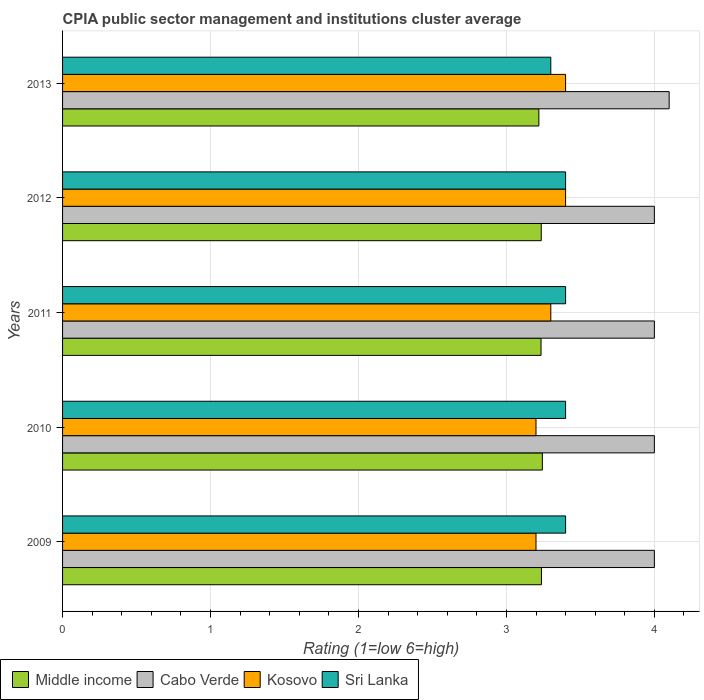How many different coloured bars are there?
Give a very brief answer. 4. Are the number of bars per tick equal to the number of legend labels?
Offer a terse response. Yes. Are the number of bars on each tick of the Y-axis equal?
Provide a short and direct response. Yes. How many bars are there on the 4th tick from the top?
Your answer should be very brief. 4. How many bars are there on the 4th tick from the bottom?
Your response must be concise. 4. What is the label of the 3rd group of bars from the top?
Provide a short and direct response. 2011. In how many cases, is the number of bars for a given year not equal to the number of legend labels?
Ensure brevity in your answer.  0. What is the CPIA rating in Cabo Verde in 2013?
Your response must be concise. 4.1. Across all years, what is the minimum CPIA rating in Sri Lanka?
Your answer should be very brief. 3.3. In which year was the CPIA rating in Cabo Verde minimum?
Give a very brief answer. 2009. What is the total CPIA rating in Cabo Verde in the graph?
Give a very brief answer. 20.1. What is the difference between the CPIA rating in Kosovo in 2011 and that in 2012?
Offer a terse response. -0.1. What is the difference between the CPIA rating in Middle income in 2011 and the CPIA rating in Sri Lanka in 2013?
Your answer should be very brief. -0.07. What is the average CPIA rating in Cabo Verde per year?
Ensure brevity in your answer.  4.02. In the year 2013, what is the difference between the CPIA rating in Kosovo and CPIA rating in Cabo Verde?
Keep it short and to the point. -0.7. In how many years, is the CPIA rating in Sri Lanka greater than 1 ?
Offer a very short reply. 5. What is the ratio of the CPIA rating in Cabo Verde in 2011 to that in 2013?
Offer a very short reply. 0.98. What is the difference between the highest and the second highest CPIA rating in Sri Lanka?
Provide a succinct answer. 0. What is the difference between the highest and the lowest CPIA rating in Kosovo?
Your response must be concise. 0.2. In how many years, is the CPIA rating in Kosovo greater than the average CPIA rating in Kosovo taken over all years?
Give a very brief answer. 2. Is it the case that in every year, the sum of the CPIA rating in Sri Lanka and CPIA rating in Kosovo is greater than the sum of CPIA rating in Cabo Verde and CPIA rating in Middle income?
Provide a short and direct response. No. What does the 1st bar from the bottom in 2009 represents?
Make the answer very short. Middle income. Is it the case that in every year, the sum of the CPIA rating in Middle income and CPIA rating in Cabo Verde is greater than the CPIA rating in Sri Lanka?
Give a very brief answer. Yes. Are all the bars in the graph horizontal?
Offer a very short reply. Yes. How many years are there in the graph?
Your answer should be very brief. 5. Does the graph contain any zero values?
Give a very brief answer. No. How many legend labels are there?
Offer a terse response. 4. How are the legend labels stacked?
Provide a succinct answer. Horizontal. What is the title of the graph?
Offer a very short reply. CPIA public sector management and institutions cluster average. What is the Rating (1=low 6=high) of Middle income in 2009?
Provide a succinct answer. 3.24. What is the Rating (1=low 6=high) of Cabo Verde in 2009?
Offer a very short reply. 4. What is the Rating (1=low 6=high) in Sri Lanka in 2009?
Offer a terse response. 3.4. What is the Rating (1=low 6=high) in Middle income in 2010?
Your answer should be very brief. 3.24. What is the Rating (1=low 6=high) in Cabo Verde in 2010?
Offer a very short reply. 4. What is the Rating (1=low 6=high) in Kosovo in 2010?
Offer a terse response. 3.2. What is the Rating (1=low 6=high) in Middle income in 2011?
Provide a succinct answer. 3.23. What is the Rating (1=low 6=high) of Cabo Verde in 2011?
Ensure brevity in your answer.  4. What is the Rating (1=low 6=high) of Sri Lanka in 2011?
Your answer should be very brief. 3.4. What is the Rating (1=low 6=high) of Middle income in 2012?
Offer a terse response. 3.24. What is the Rating (1=low 6=high) of Cabo Verde in 2012?
Your answer should be very brief. 4. What is the Rating (1=low 6=high) in Kosovo in 2012?
Provide a succinct answer. 3.4. What is the Rating (1=low 6=high) of Middle income in 2013?
Keep it short and to the point. 3.22. Across all years, what is the maximum Rating (1=low 6=high) in Middle income?
Provide a short and direct response. 3.24. Across all years, what is the maximum Rating (1=low 6=high) of Kosovo?
Offer a terse response. 3.4. Across all years, what is the minimum Rating (1=low 6=high) of Middle income?
Your answer should be very brief. 3.22. Across all years, what is the minimum Rating (1=low 6=high) of Cabo Verde?
Your response must be concise. 4. Across all years, what is the minimum Rating (1=low 6=high) of Kosovo?
Your answer should be compact. 3.2. Across all years, what is the minimum Rating (1=low 6=high) of Sri Lanka?
Your answer should be compact. 3.3. What is the total Rating (1=low 6=high) in Middle income in the graph?
Make the answer very short. 16.17. What is the total Rating (1=low 6=high) of Cabo Verde in the graph?
Your answer should be compact. 20.1. What is the total Rating (1=low 6=high) in Kosovo in the graph?
Provide a succinct answer. 16.5. What is the total Rating (1=low 6=high) of Sri Lanka in the graph?
Your answer should be compact. 16.9. What is the difference between the Rating (1=low 6=high) of Middle income in 2009 and that in 2010?
Keep it short and to the point. -0.01. What is the difference between the Rating (1=low 6=high) in Sri Lanka in 2009 and that in 2010?
Provide a succinct answer. 0. What is the difference between the Rating (1=low 6=high) in Middle income in 2009 and that in 2011?
Offer a very short reply. 0. What is the difference between the Rating (1=low 6=high) of Kosovo in 2009 and that in 2011?
Offer a terse response. -0.1. What is the difference between the Rating (1=low 6=high) of Middle income in 2009 and that in 2012?
Offer a terse response. 0. What is the difference between the Rating (1=low 6=high) of Sri Lanka in 2009 and that in 2012?
Ensure brevity in your answer.  0. What is the difference between the Rating (1=low 6=high) of Middle income in 2009 and that in 2013?
Give a very brief answer. 0.02. What is the difference between the Rating (1=low 6=high) in Cabo Verde in 2009 and that in 2013?
Your answer should be very brief. -0.1. What is the difference between the Rating (1=low 6=high) in Kosovo in 2009 and that in 2013?
Your answer should be compact. -0.2. What is the difference between the Rating (1=low 6=high) of Middle income in 2010 and that in 2011?
Give a very brief answer. 0.01. What is the difference between the Rating (1=low 6=high) of Cabo Verde in 2010 and that in 2011?
Provide a succinct answer. 0. What is the difference between the Rating (1=low 6=high) in Kosovo in 2010 and that in 2011?
Keep it short and to the point. -0.1. What is the difference between the Rating (1=low 6=high) of Middle income in 2010 and that in 2012?
Provide a succinct answer. 0.01. What is the difference between the Rating (1=low 6=high) in Kosovo in 2010 and that in 2012?
Provide a short and direct response. -0.2. What is the difference between the Rating (1=low 6=high) of Middle income in 2010 and that in 2013?
Offer a very short reply. 0.02. What is the difference between the Rating (1=low 6=high) in Cabo Verde in 2010 and that in 2013?
Your answer should be very brief. -0.1. What is the difference between the Rating (1=low 6=high) of Kosovo in 2010 and that in 2013?
Offer a very short reply. -0.2. What is the difference between the Rating (1=low 6=high) of Middle income in 2011 and that in 2012?
Make the answer very short. -0. What is the difference between the Rating (1=low 6=high) in Kosovo in 2011 and that in 2012?
Give a very brief answer. -0.1. What is the difference between the Rating (1=low 6=high) of Middle income in 2011 and that in 2013?
Your answer should be compact. 0.01. What is the difference between the Rating (1=low 6=high) in Kosovo in 2011 and that in 2013?
Ensure brevity in your answer.  -0.1. What is the difference between the Rating (1=low 6=high) of Middle income in 2012 and that in 2013?
Your answer should be very brief. 0.02. What is the difference between the Rating (1=low 6=high) in Cabo Verde in 2012 and that in 2013?
Keep it short and to the point. -0.1. What is the difference between the Rating (1=low 6=high) of Kosovo in 2012 and that in 2013?
Your answer should be very brief. 0. What is the difference between the Rating (1=low 6=high) in Middle income in 2009 and the Rating (1=low 6=high) in Cabo Verde in 2010?
Offer a very short reply. -0.76. What is the difference between the Rating (1=low 6=high) of Middle income in 2009 and the Rating (1=low 6=high) of Kosovo in 2010?
Provide a succinct answer. 0.04. What is the difference between the Rating (1=low 6=high) of Middle income in 2009 and the Rating (1=low 6=high) of Sri Lanka in 2010?
Ensure brevity in your answer.  -0.16. What is the difference between the Rating (1=low 6=high) of Cabo Verde in 2009 and the Rating (1=low 6=high) of Kosovo in 2010?
Keep it short and to the point. 0.8. What is the difference between the Rating (1=low 6=high) of Cabo Verde in 2009 and the Rating (1=low 6=high) of Sri Lanka in 2010?
Your answer should be very brief. 0.6. What is the difference between the Rating (1=low 6=high) of Kosovo in 2009 and the Rating (1=low 6=high) of Sri Lanka in 2010?
Provide a short and direct response. -0.2. What is the difference between the Rating (1=low 6=high) in Middle income in 2009 and the Rating (1=low 6=high) in Cabo Verde in 2011?
Ensure brevity in your answer.  -0.76. What is the difference between the Rating (1=low 6=high) in Middle income in 2009 and the Rating (1=low 6=high) in Kosovo in 2011?
Your answer should be compact. -0.06. What is the difference between the Rating (1=low 6=high) of Middle income in 2009 and the Rating (1=low 6=high) of Sri Lanka in 2011?
Your answer should be very brief. -0.16. What is the difference between the Rating (1=low 6=high) in Cabo Verde in 2009 and the Rating (1=low 6=high) in Kosovo in 2011?
Offer a very short reply. 0.7. What is the difference between the Rating (1=low 6=high) of Kosovo in 2009 and the Rating (1=low 6=high) of Sri Lanka in 2011?
Provide a succinct answer. -0.2. What is the difference between the Rating (1=low 6=high) in Middle income in 2009 and the Rating (1=low 6=high) in Cabo Verde in 2012?
Make the answer very short. -0.76. What is the difference between the Rating (1=low 6=high) in Middle income in 2009 and the Rating (1=low 6=high) in Kosovo in 2012?
Ensure brevity in your answer.  -0.16. What is the difference between the Rating (1=low 6=high) in Middle income in 2009 and the Rating (1=low 6=high) in Sri Lanka in 2012?
Your answer should be very brief. -0.16. What is the difference between the Rating (1=low 6=high) of Cabo Verde in 2009 and the Rating (1=low 6=high) of Kosovo in 2012?
Give a very brief answer. 0.6. What is the difference between the Rating (1=low 6=high) of Middle income in 2009 and the Rating (1=low 6=high) of Cabo Verde in 2013?
Your response must be concise. -0.86. What is the difference between the Rating (1=low 6=high) in Middle income in 2009 and the Rating (1=low 6=high) in Kosovo in 2013?
Your response must be concise. -0.16. What is the difference between the Rating (1=low 6=high) in Middle income in 2009 and the Rating (1=low 6=high) in Sri Lanka in 2013?
Ensure brevity in your answer.  -0.06. What is the difference between the Rating (1=low 6=high) of Kosovo in 2009 and the Rating (1=low 6=high) of Sri Lanka in 2013?
Make the answer very short. -0.1. What is the difference between the Rating (1=low 6=high) of Middle income in 2010 and the Rating (1=low 6=high) of Cabo Verde in 2011?
Ensure brevity in your answer.  -0.76. What is the difference between the Rating (1=low 6=high) of Middle income in 2010 and the Rating (1=low 6=high) of Kosovo in 2011?
Provide a short and direct response. -0.06. What is the difference between the Rating (1=low 6=high) of Middle income in 2010 and the Rating (1=low 6=high) of Sri Lanka in 2011?
Your answer should be very brief. -0.16. What is the difference between the Rating (1=low 6=high) in Middle income in 2010 and the Rating (1=low 6=high) in Cabo Verde in 2012?
Ensure brevity in your answer.  -0.76. What is the difference between the Rating (1=low 6=high) of Middle income in 2010 and the Rating (1=low 6=high) of Kosovo in 2012?
Ensure brevity in your answer.  -0.16. What is the difference between the Rating (1=low 6=high) in Middle income in 2010 and the Rating (1=low 6=high) in Sri Lanka in 2012?
Offer a terse response. -0.16. What is the difference between the Rating (1=low 6=high) of Cabo Verde in 2010 and the Rating (1=low 6=high) of Kosovo in 2012?
Ensure brevity in your answer.  0.6. What is the difference between the Rating (1=low 6=high) in Cabo Verde in 2010 and the Rating (1=low 6=high) in Sri Lanka in 2012?
Provide a short and direct response. 0.6. What is the difference between the Rating (1=low 6=high) of Kosovo in 2010 and the Rating (1=low 6=high) of Sri Lanka in 2012?
Ensure brevity in your answer.  -0.2. What is the difference between the Rating (1=low 6=high) of Middle income in 2010 and the Rating (1=low 6=high) of Cabo Verde in 2013?
Make the answer very short. -0.86. What is the difference between the Rating (1=low 6=high) of Middle income in 2010 and the Rating (1=low 6=high) of Kosovo in 2013?
Offer a very short reply. -0.16. What is the difference between the Rating (1=low 6=high) in Middle income in 2010 and the Rating (1=low 6=high) in Sri Lanka in 2013?
Provide a succinct answer. -0.06. What is the difference between the Rating (1=low 6=high) in Cabo Verde in 2010 and the Rating (1=low 6=high) in Kosovo in 2013?
Provide a succinct answer. 0.6. What is the difference between the Rating (1=low 6=high) of Kosovo in 2010 and the Rating (1=low 6=high) of Sri Lanka in 2013?
Offer a very short reply. -0.1. What is the difference between the Rating (1=low 6=high) of Middle income in 2011 and the Rating (1=low 6=high) of Cabo Verde in 2012?
Provide a succinct answer. -0.77. What is the difference between the Rating (1=low 6=high) in Middle income in 2011 and the Rating (1=low 6=high) in Kosovo in 2012?
Provide a short and direct response. -0.17. What is the difference between the Rating (1=low 6=high) in Middle income in 2011 and the Rating (1=low 6=high) in Sri Lanka in 2012?
Keep it short and to the point. -0.17. What is the difference between the Rating (1=low 6=high) of Kosovo in 2011 and the Rating (1=low 6=high) of Sri Lanka in 2012?
Your answer should be very brief. -0.1. What is the difference between the Rating (1=low 6=high) in Middle income in 2011 and the Rating (1=low 6=high) in Cabo Verde in 2013?
Provide a short and direct response. -0.87. What is the difference between the Rating (1=low 6=high) of Middle income in 2011 and the Rating (1=low 6=high) of Kosovo in 2013?
Give a very brief answer. -0.17. What is the difference between the Rating (1=low 6=high) of Middle income in 2011 and the Rating (1=low 6=high) of Sri Lanka in 2013?
Provide a short and direct response. -0.07. What is the difference between the Rating (1=low 6=high) in Cabo Verde in 2011 and the Rating (1=low 6=high) in Sri Lanka in 2013?
Offer a very short reply. 0.7. What is the difference between the Rating (1=low 6=high) of Kosovo in 2011 and the Rating (1=low 6=high) of Sri Lanka in 2013?
Offer a very short reply. 0. What is the difference between the Rating (1=low 6=high) of Middle income in 2012 and the Rating (1=low 6=high) of Cabo Verde in 2013?
Offer a terse response. -0.86. What is the difference between the Rating (1=low 6=high) in Middle income in 2012 and the Rating (1=low 6=high) in Kosovo in 2013?
Your answer should be very brief. -0.16. What is the difference between the Rating (1=low 6=high) in Middle income in 2012 and the Rating (1=low 6=high) in Sri Lanka in 2013?
Provide a succinct answer. -0.06. What is the difference between the Rating (1=low 6=high) of Cabo Verde in 2012 and the Rating (1=low 6=high) of Kosovo in 2013?
Provide a succinct answer. 0.6. What is the difference between the Rating (1=low 6=high) in Cabo Verde in 2012 and the Rating (1=low 6=high) in Sri Lanka in 2013?
Your answer should be very brief. 0.7. What is the difference between the Rating (1=low 6=high) of Kosovo in 2012 and the Rating (1=low 6=high) of Sri Lanka in 2013?
Your response must be concise. 0.1. What is the average Rating (1=low 6=high) of Middle income per year?
Your answer should be very brief. 3.23. What is the average Rating (1=low 6=high) in Cabo Verde per year?
Ensure brevity in your answer.  4.02. What is the average Rating (1=low 6=high) in Sri Lanka per year?
Your answer should be very brief. 3.38. In the year 2009, what is the difference between the Rating (1=low 6=high) of Middle income and Rating (1=low 6=high) of Cabo Verde?
Give a very brief answer. -0.76. In the year 2009, what is the difference between the Rating (1=low 6=high) in Middle income and Rating (1=low 6=high) in Kosovo?
Your response must be concise. 0.04. In the year 2009, what is the difference between the Rating (1=low 6=high) in Middle income and Rating (1=low 6=high) in Sri Lanka?
Give a very brief answer. -0.16. In the year 2009, what is the difference between the Rating (1=low 6=high) in Kosovo and Rating (1=low 6=high) in Sri Lanka?
Keep it short and to the point. -0.2. In the year 2010, what is the difference between the Rating (1=low 6=high) of Middle income and Rating (1=low 6=high) of Cabo Verde?
Offer a terse response. -0.76. In the year 2010, what is the difference between the Rating (1=low 6=high) of Middle income and Rating (1=low 6=high) of Kosovo?
Give a very brief answer. 0.04. In the year 2010, what is the difference between the Rating (1=low 6=high) of Middle income and Rating (1=low 6=high) of Sri Lanka?
Offer a very short reply. -0.16. In the year 2011, what is the difference between the Rating (1=low 6=high) of Middle income and Rating (1=low 6=high) of Cabo Verde?
Keep it short and to the point. -0.77. In the year 2011, what is the difference between the Rating (1=low 6=high) in Middle income and Rating (1=low 6=high) in Kosovo?
Offer a very short reply. -0.07. In the year 2011, what is the difference between the Rating (1=low 6=high) of Middle income and Rating (1=low 6=high) of Sri Lanka?
Offer a terse response. -0.17. In the year 2011, what is the difference between the Rating (1=low 6=high) of Cabo Verde and Rating (1=low 6=high) of Kosovo?
Your response must be concise. 0.7. In the year 2011, what is the difference between the Rating (1=low 6=high) of Cabo Verde and Rating (1=low 6=high) of Sri Lanka?
Offer a very short reply. 0.6. In the year 2012, what is the difference between the Rating (1=low 6=high) in Middle income and Rating (1=low 6=high) in Cabo Verde?
Keep it short and to the point. -0.76. In the year 2012, what is the difference between the Rating (1=low 6=high) of Middle income and Rating (1=low 6=high) of Kosovo?
Offer a very short reply. -0.16. In the year 2012, what is the difference between the Rating (1=low 6=high) of Middle income and Rating (1=low 6=high) of Sri Lanka?
Give a very brief answer. -0.16. In the year 2012, what is the difference between the Rating (1=low 6=high) of Cabo Verde and Rating (1=low 6=high) of Kosovo?
Offer a terse response. 0.6. In the year 2012, what is the difference between the Rating (1=low 6=high) of Cabo Verde and Rating (1=low 6=high) of Sri Lanka?
Offer a very short reply. 0.6. In the year 2012, what is the difference between the Rating (1=low 6=high) in Kosovo and Rating (1=low 6=high) in Sri Lanka?
Ensure brevity in your answer.  0. In the year 2013, what is the difference between the Rating (1=low 6=high) in Middle income and Rating (1=low 6=high) in Cabo Verde?
Make the answer very short. -0.88. In the year 2013, what is the difference between the Rating (1=low 6=high) of Middle income and Rating (1=low 6=high) of Kosovo?
Your response must be concise. -0.18. In the year 2013, what is the difference between the Rating (1=low 6=high) in Middle income and Rating (1=low 6=high) in Sri Lanka?
Your response must be concise. -0.08. In the year 2013, what is the difference between the Rating (1=low 6=high) of Cabo Verde and Rating (1=low 6=high) of Sri Lanka?
Provide a succinct answer. 0.8. What is the ratio of the Rating (1=low 6=high) in Cabo Verde in 2009 to that in 2010?
Offer a terse response. 1. What is the ratio of the Rating (1=low 6=high) in Kosovo in 2009 to that in 2010?
Offer a very short reply. 1. What is the ratio of the Rating (1=low 6=high) of Middle income in 2009 to that in 2011?
Your answer should be very brief. 1. What is the ratio of the Rating (1=low 6=high) in Kosovo in 2009 to that in 2011?
Offer a terse response. 0.97. What is the ratio of the Rating (1=low 6=high) of Sri Lanka in 2009 to that in 2011?
Make the answer very short. 1. What is the ratio of the Rating (1=low 6=high) of Middle income in 2009 to that in 2012?
Ensure brevity in your answer.  1. What is the ratio of the Rating (1=low 6=high) of Cabo Verde in 2009 to that in 2012?
Keep it short and to the point. 1. What is the ratio of the Rating (1=low 6=high) of Kosovo in 2009 to that in 2012?
Keep it short and to the point. 0.94. What is the ratio of the Rating (1=low 6=high) of Middle income in 2009 to that in 2013?
Your response must be concise. 1.01. What is the ratio of the Rating (1=low 6=high) in Cabo Verde in 2009 to that in 2013?
Offer a terse response. 0.98. What is the ratio of the Rating (1=low 6=high) in Sri Lanka in 2009 to that in 2013?
Your answer should be compact. 1.03. What is the ratio of the Rating (1=low 6=high) in Middle income in 2010 to that in 2011?
Your response must be concise. 1. What is the ratio of the Rating (1=low 6=high) in Kosovo in 2010 to that in 2011?
Give a very brief answer. 0.97. What is the ratio of the Rating (1=low 6=high) of Sri Lanka in 2010 to that in 2011?
Ensure brevity in your answer.  1. What is the ratio of the Rating (1=low 6=high) of Middle income in 2010 to that in 2013?
Provide a succinct answer. 1.01. What is the ratio of the Rating (1=low 6=high) of Cabo Verde in 2010 to that in 2013?
Offer a very short reply. 0.98. What is the ratio of the Rating (1=low 6=high) in Sri Lanka in 2010 to that in 2013?
Provide a succinct answer. 1.03. What is the ratio of the Rating (1=low 6=high) in Middle income in 2011 to that in 2012?
Provide a succinct answer. 1. What is the ratio of the Rating (1=low 6=high) in Cabo Verde in 2011 to that in 2012?
Provide a succinct answer. 1. What is the ratio of the Rating (1=low 6=high) in Kosovo in 2011 to that in 2012?
Give a very brief answer. 0.97. What is the ratio of the Rating (1=low 6=high) of Middle income in 2011 to that in 2013?
Make the answer very short. 1. What is the ratio of the Rating (1=low 6=high) in Cabo Verde in 2011 to that in 2013?
Provide a short and direct response. 0.98. What is the ratio of the Rating (1=low 6=high) in Kosovo in 2011 to that in 2013?
Your answer should be very brief. 0.97. What is the ratio of the Rating (1=low 6=high) of Sri Lanka in 2011 to that in 2013?
Your response must be concise. 1.03. What is the ratio of the Rating (1=low 6=high) in Cabo Verde in 2012 to that in 2013?
Provide a succinct answer. 0.98. What is the ratio of the Rating (1=low 6=high) in Sri Lanka in 2012 to that in 2013?
Give a very brief answer. 1.03. What is the difference between the highest and the second highest Rating (1=low 6=high) in Middle income?
Your answer should be compact. 0.01. What is the difference between the highest and the second highest Rating (1=low 6=high) in Kosovo?
Ensure brevity in your answer.  0. What is the difference between the highest and the lowest Rating (1=low 6=high) in Middle income?
Your answer should be compact. 0.02. What is the difference between the highest and the lowest Rating (1=low 6=high) of Cabo Verde?
Ensure brevity in your answer.  0.1. What is the difference between the highest and the lowest Rating (1=low 6=high) of Kosovo?
Your response must be concise. 0.2. What is the difference between the highest and the lowest Rating (1=low 6=high) of Sri Lanka?
Make the answer very short. 0.1. 